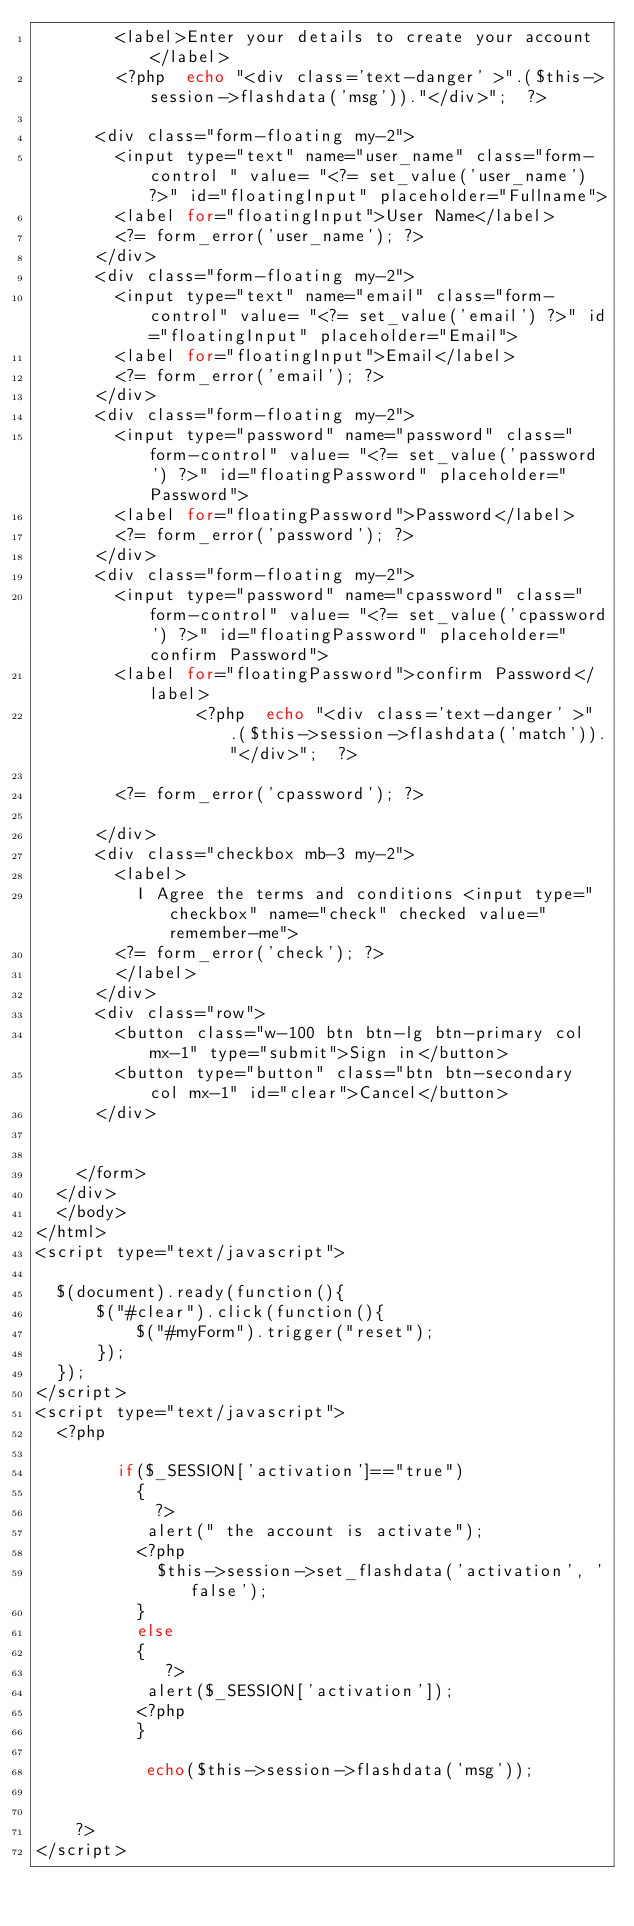Convert code to text. <code><loc_0><loc_0><loc_500><loc_500><_PHP_>        <label>Enter your details to create your account</label>
        <?php  echo "<div class='text-danger' >".($this->session->flashdata('msg'))."</div>";  ?>

      <div class="form-floating my-2">
        <input type="text" name="user_name" class="form-control " value= "<?= set_value('user_name') ?>" id="floatingInput" placeholder="Fullname">
        <label for="floatingInput">User Name</label>
        <?= form_error('user_name'); ?>
      </div>
      <div class="form-floating my-2">
        <input type="text" name="email" class="form-control" value= "<?= set_value('email') ?>" id="floatingInput" placeholder="Email">
        <label for="floatingInput">Email</label>
        <?= form_error('email'); ?>
      </div>
      <div class="form-floating my-2">
        <input type="password" name="password" class="form-control" value= "<?= set_value('password') ?>" id="floatingPassword" placeholder="Password">
        <label for="floatingPassword">Password</label>
        <?= form_error('password'); ?>
      </div>
      <div class="form-floating my-2">
        <input type="password" name="cpassword" class="form-control" value= "<?= set_value('cpassword') ?>" id="floatingPassword" placeholder="confirm Password">
        <label for="floatingPassword">confirm Password</label>
                <?php  echo "<div class='text-danger' >".($this->session->flashdata('match'))."</div>";  ?>

        <?= form_error('cpassword'); ?>

      </div>
      <div class="checkbox mb-3 my-2">
        <label>
          I Agree the terms and conditions <input type="checkbox" name="check" checked value="remember-me">
        <?= form_error('check'); ?>
        </label>
      </div>
      <div class="row">
        <button class="w-100 btn btn-lg btn-primary col mx-1" type="submit">Sign in</button>
        <button type="button" class="btn btn-secondary col mx-1" id="clear">Cancel</button>
      </div>
      

    </form>
  </div>
  </body>
</html>
<script type="text/javascript">

  $(document).ready(function(){
      $("#clear").click(function(){
          $("#myForm").trigger("reset");
      });
  });
</script>
<script type="text/javascript">
  <?php   

        if($_SESSION['activation']=="true")
          {
            ?>
           alert(" the account is activate");
          <?php
            $this->session->set_flashdata('activation', 'false');
          }
          else
          {
             ?>
           alert($_SESSION['activation']);
          <?php
          }

           echo($this->session->flashdata('msg'));
                    

    ?>
</script></code> 